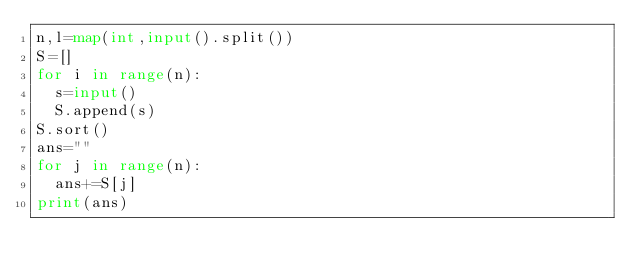Convert code to text. <code><loc_0><loc_0><loc_500><loc_500><_Python_>n,l=map(int,input().split())
S=[]
for i in range(n):
  s=input()
  S.append(s)
S.sort()
ans=""
for j in range(n):
  ans+=S[j]
print(ans)</code> 